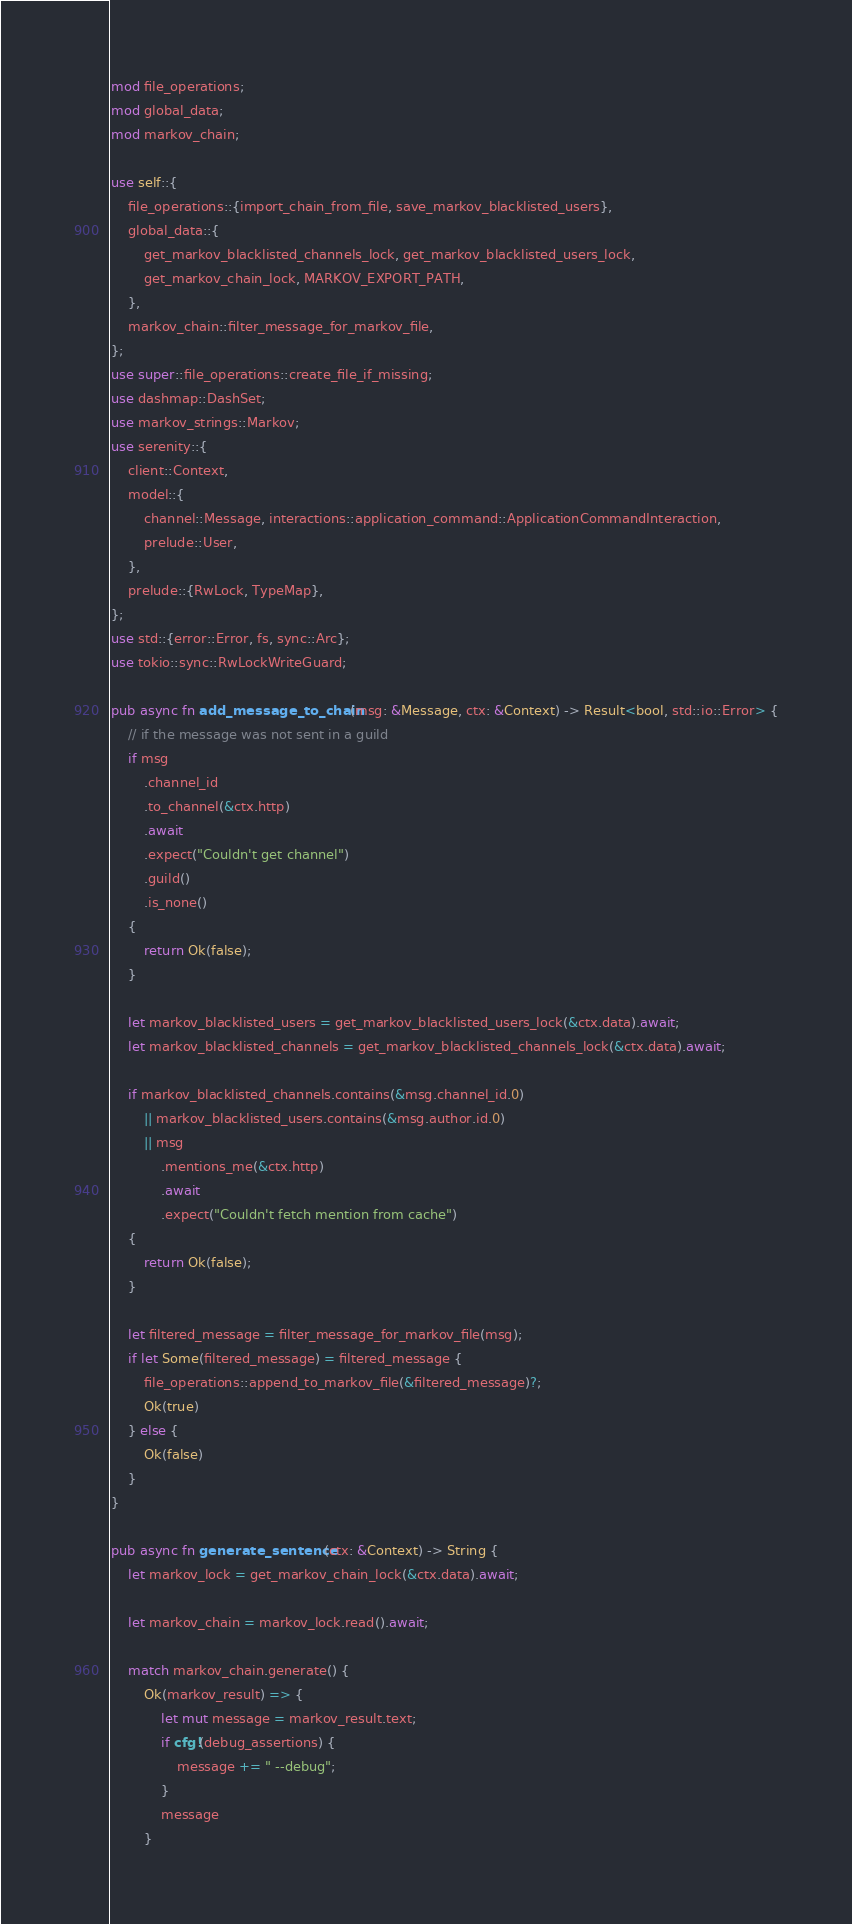<code> <loc_0><loc_0><loc_500><loc_500><_Rust_>mod file_operations;
mod global_data;
mod markov_chain;

use self::{
    file_operations::{import_chain_from_file, save_markov_blacklisted_users},
    global_data::{
        get_markov_blacklisted_channels_lock, get_markov_blacklisted_users_lock,
        get_markov_chain_lock, MARKOV_EXPORT_PATH,
    },
    markov_chain::filter_message_for_markov_file,
};
use super::file_operations::create_file_if_missing;
use dashmap::DashSet;
use markov_strings::Markov;
use serenity::{
    client::Context,
    model::{
        channel::Message, interactions::application_command::ApplicationCommandInteraction,
        prelude::User,
    },
    prelude::{RwLock, TypeMap},
};
use std::{error::Error, fs, sync::Arc};
use tokio::sync::RwLockWriteGuard;

pub async fn add_message_to_chain(msg: &Message, ctx: &Context) -> Result<bool, std::io::Error> {
    // if the message was not sent in a guild
    if msg
        .channel_id
        .to_channel(&ctx.http)
        .await
        .expect("Couldn't get channel")
        .guild()
        .is_none()
    {
        return Ok(false);
    }

    let markov_blacklisted_users = get_markov_blacklisted_users_lock(&ctx.data).await;
    let markov_blacklisted_channels = get_markov_blacklisted_channels_lock(&ctx.data).await;

    if markov_blacklisted_channels.contains(&msg.channel_id.0)
        || markov_blacklisted_users.contains(&msg.author.id.0)
        || msg
            .mentions_me(&ctx.http)
            .await
            .expect("Couldn't fetch mention from cache")
    {
        return Ok(false);
    }

    let filtered_message = filter_message_for_markov_file(msg);
    if let Some(filtered_message) = filtered_message {
        file_operations::append_to_markov_file(&filtered_message)?;
        Ok(true)
    } else {
        Ok(false)
    }
}

pub async fn generate_sentence(ctx: &Context) -> String {
    let markov_lock = get_markov_chain_lock(&ctx.data).await;

    let markov_chain = markov_lock.read().await;

    match markov_chain.generate() {
        Ok(markov_result) => {
            let mut message = markov_result.text;
            if cfg!(debug_assertions) {
                message += " --debug";
            }
            message
        }</code> 